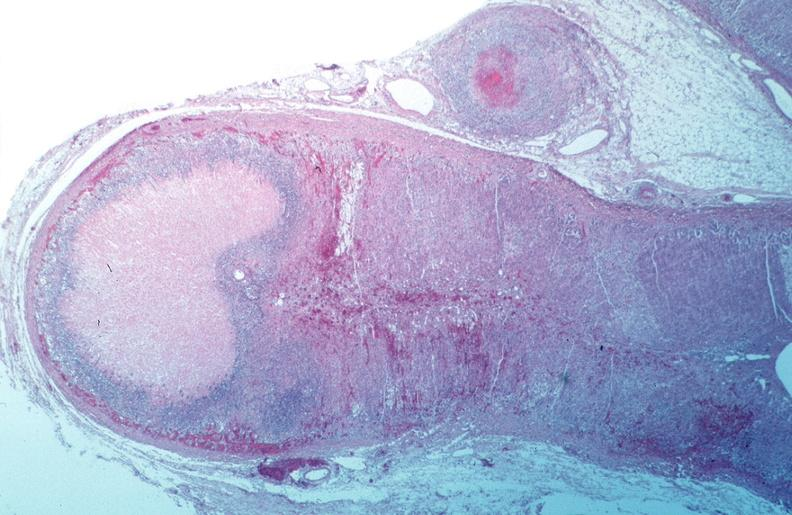where is this from?
Answer the question using a single word or phrase. Vasculature 